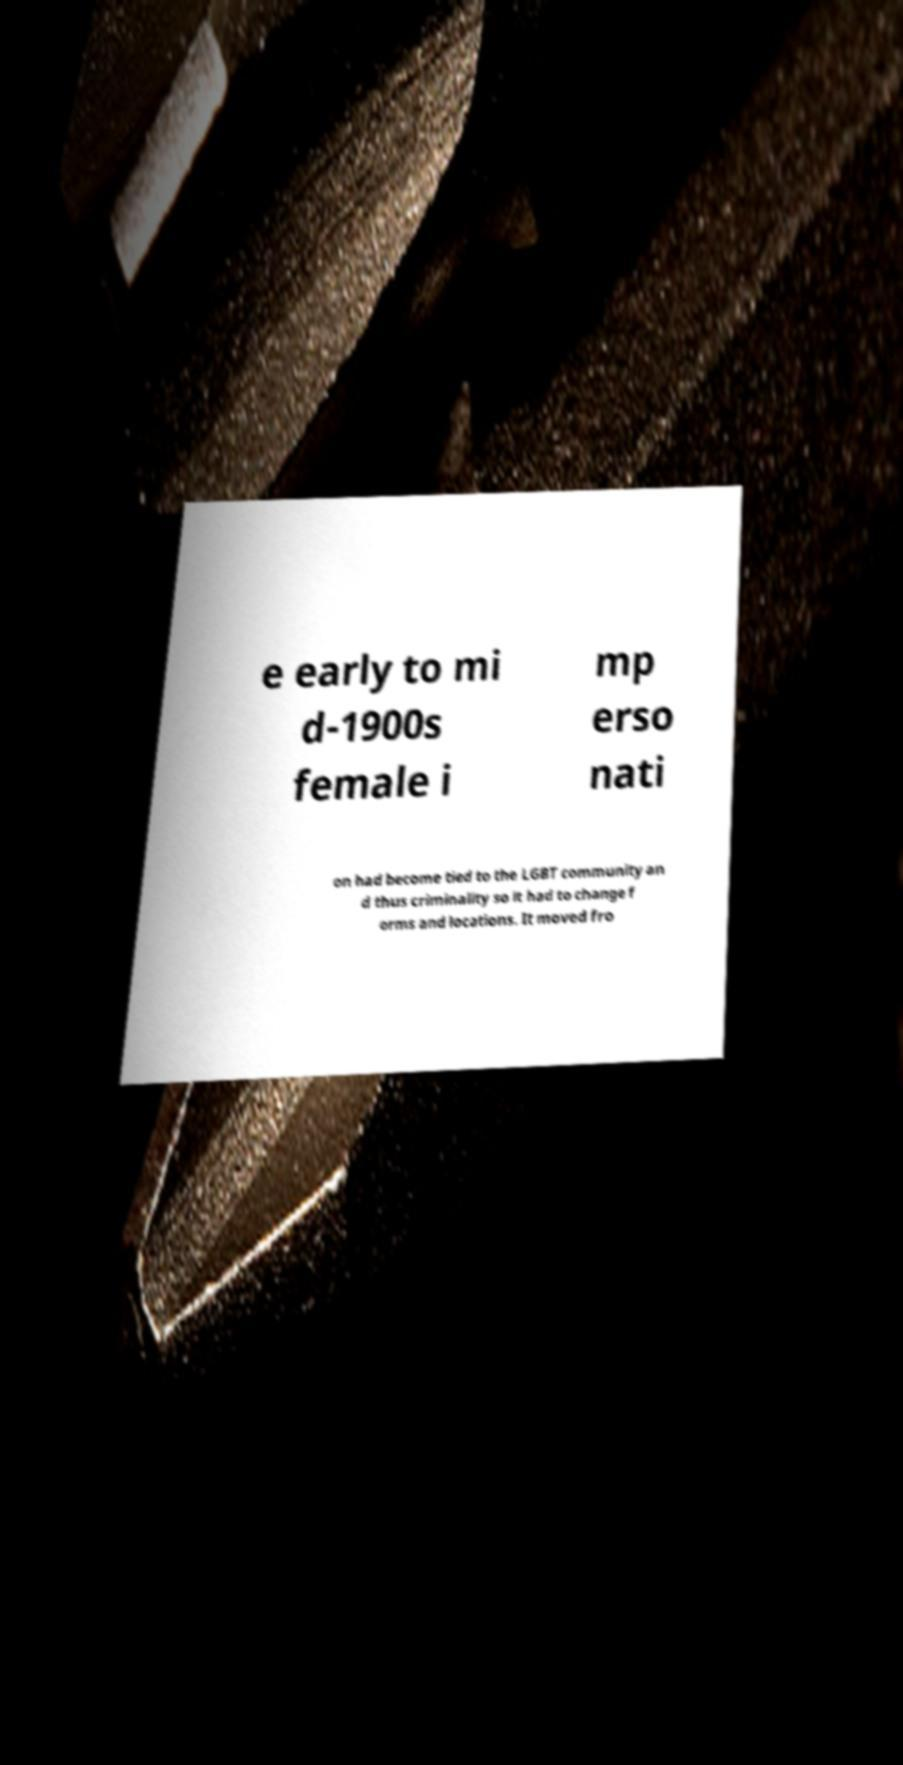Can you read and provide the text displayed in the image?This photo seems to have some interesting text. Can you extract and type it out for me? e early to mi d-1900s female i mp erso nati on had become tied to the LGBT community an d thus criminality so it had to change f orms and locations. It moved fro 